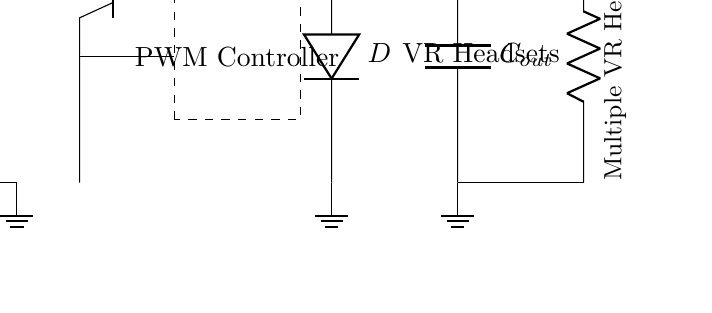What is the type of transistor used in this circuit? The circuit uses a NPN transistor, which is indicated by the label "npn" next to the transistor symbol in the diagram.
Answer: NPN What component is responsible for converting the input voltage to a different level? The PWM controller is the element that modulates the input voltage to produce a varying output voltage suited for the load. It can be found in the dashed rectangle in the diagram.
Answer: PWM Controller What is the purpose of the inductor in this circuit? The inductor's role is to store energy and smooth out the current flowing through it, preventing sharp variations in the output voltage. This can be seen from its placement in series with the switch and diode.
Answer: Energy Storage How many outputs are shown in this circuit? The diagram shows a single output labeled for multiple VR headsets, signified by the resistor symbol connected at the output node. There is no indication of multiple separate output lines, just a single connection leading to the load.
Answer: One What is the symbol used for the output capacitor in the circuit? The capacitor is represented by the letter "C" in the circuit diagram, followed by a subscript "out," which specifies that this particular capacitor is for the output.
Answer: C_out What type of feedback is present in this regulator circuit? The feedback in the circuit is voltage feedback, as indicated by the arrow returning from the output, suggesting that the output voltage is being used to control the PWM controller for stable regulation.
Answer: Voltage Feedback What component will prevent reverse current flow in this circuit? The diode in the circuit, labeled "D", is responsible for this function. It allows current to flow in one direction while blocking any reverse current that could damage the circuit components.
Answer: Diode 